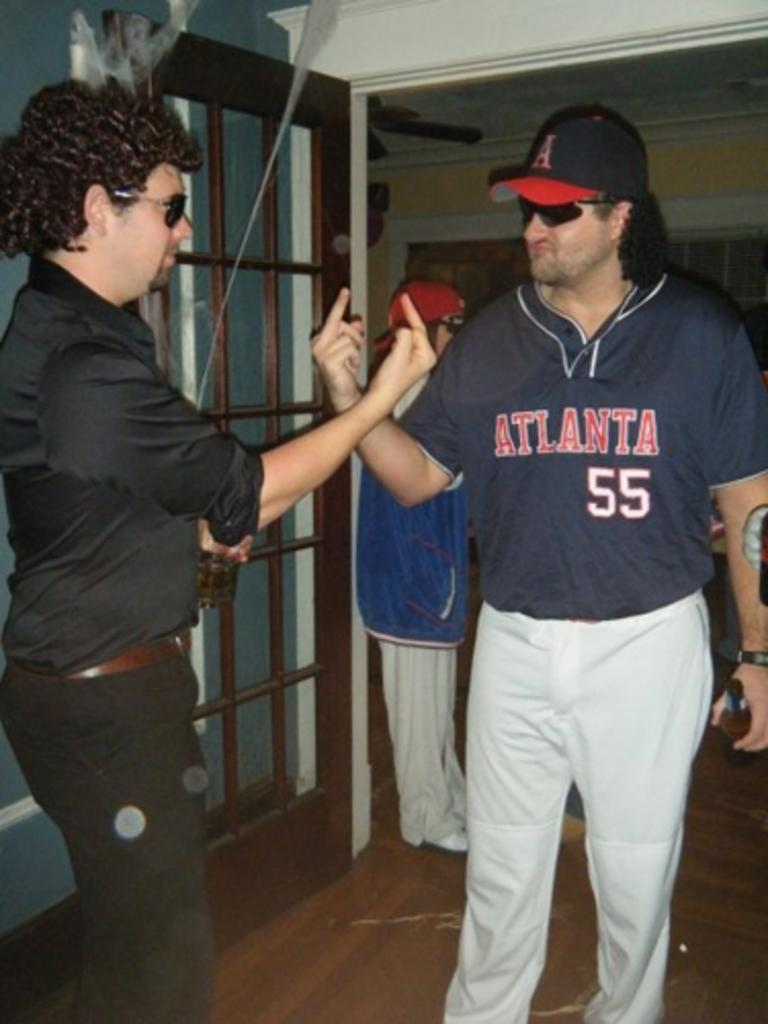<image>
Summarize the visual content of the image. Person wearing an Atlanta baseball jersey giving someone a middle finger. 